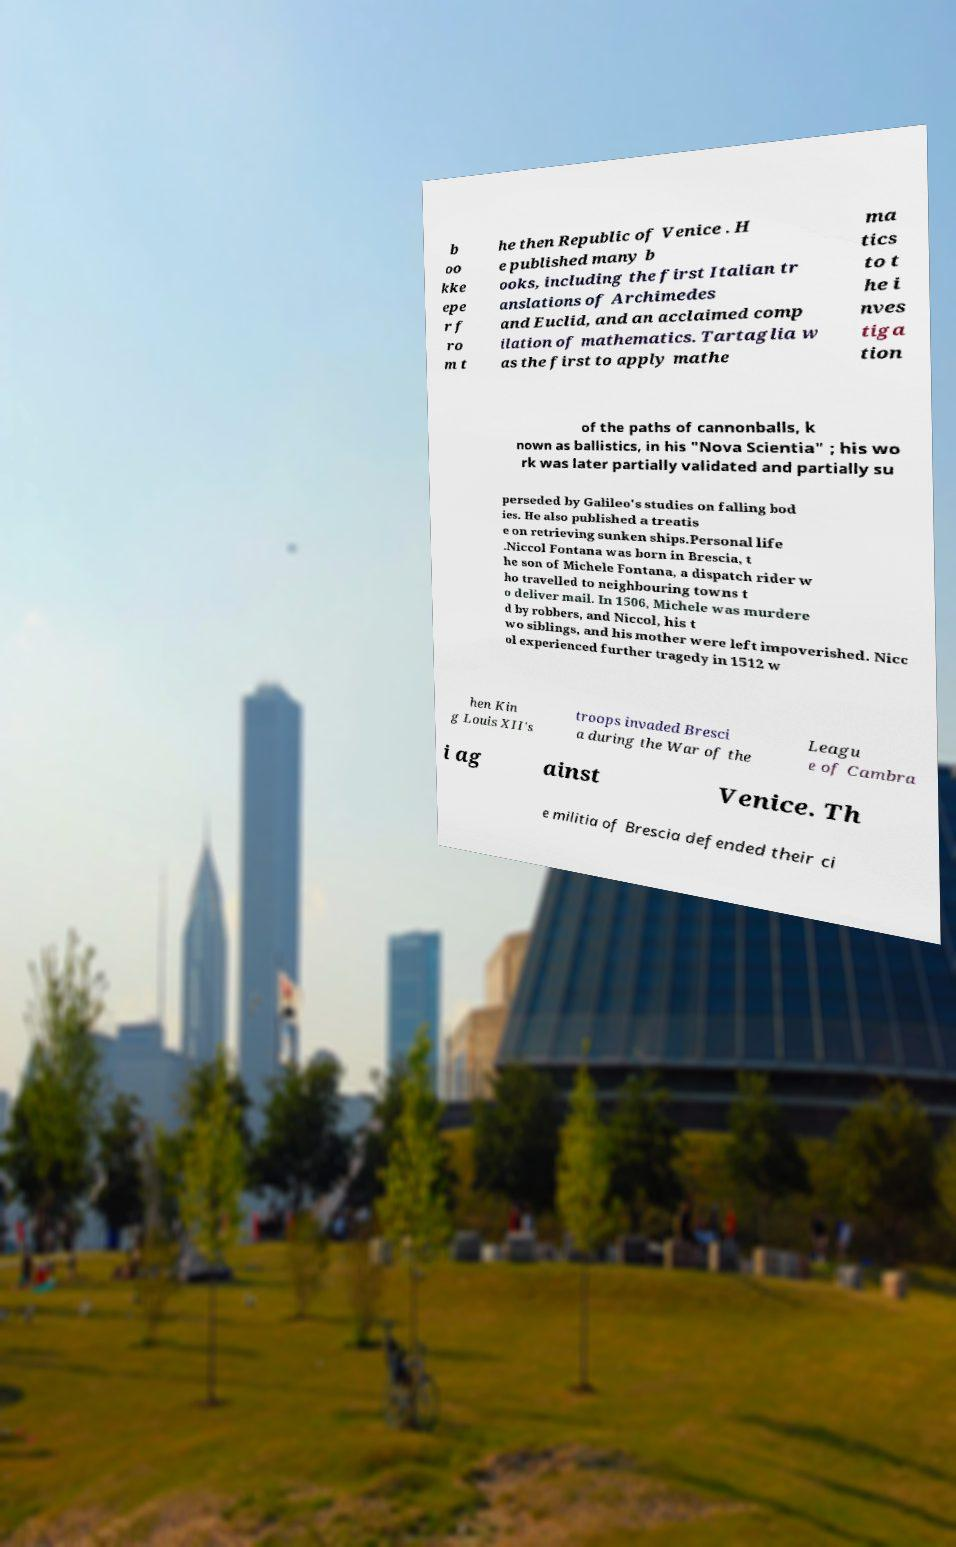Can you read and provide the text displayed in the image?This photo seems to have some interesting text. Can you extract and type it out for me? b oo kke epe r f ro m t he then Republic of Venice . H e published many b ooks, including the first Italian tr anslations of Archimedes and Euclid, and an acclaimed comp ilation of mathematics. Tartaglia w as the first to apply mathe ma tics to t he i nves tiga tion of the paths of cannonballs, k nown as ballistics, in his "Nova Scientia" ; his wo rk was later partially validated and partially su perseded by Galileo's studies on falling bod ies. He also published a treatis e on retrieving sunken ships.Personal life .Niccol Fontana was born in Brescia, t he son of Michele Fontana, a dispatch rider w ho travelled to neighbouring towns t o deliver mail. In 1506, Michele was murdere d by robbers, and Niccol, his t wo siblings, and his mother were left impoverished. Nicc ol experienced further tragedy in 1512 w hen Kin g Louis XII's troops invaded Bresci a during the War of the Leagu e of Cambra i ag ainst Venice. Th e militia of Brescia defended their ci 